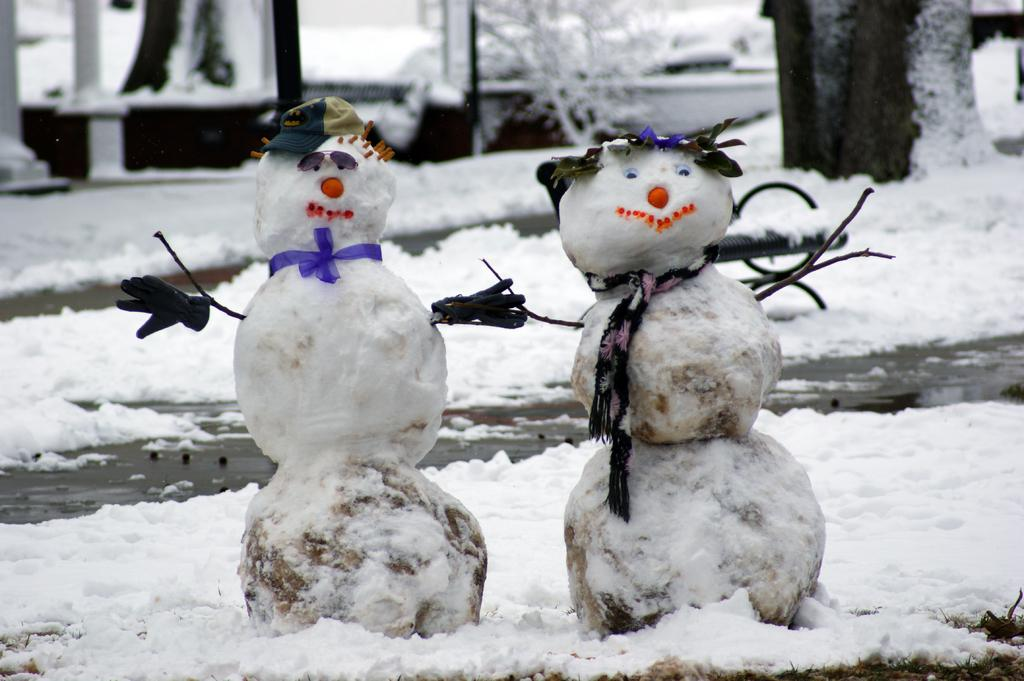What is the main subject in the center of the image? There are snowmen in the center of the image. What can be seen in the background of the image? There are trees covered by snow in the background. What type of weather is depicted in the image? Snow is present at the bottom of the image, indicating a snowy scene. How many pictures are hanging on the bridge in the image? There is no bridge or pictures present in the image; it features snowmen and snow-covered trees. 